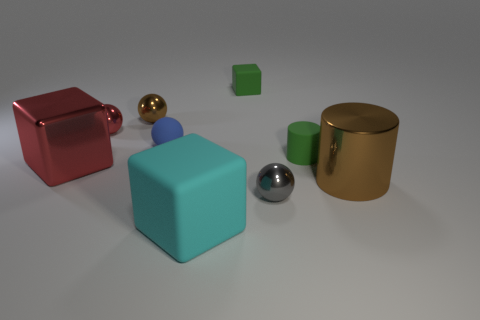What materials appear to be represented by the objects in this composition? The objects depicted in this image seem to represent a variety of materials. The red and dark brown cubes have a matte, perhaps metallic finish. The light blue cube appears slightly translucent, suggestive of an icy or glass-like material. The spheres—with one in gold and the other in silver—have reflective surfaces that could be metallic. Lastly, the light blue and green cylinders have a solid, matte finish that could represent plastic or painted metal. 